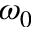<formula> <loc_0><loc_0><loc_500><loc_500>\omega _ { 0 }</formula> 